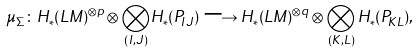Convert formula to latex. <formula><loc_0><loc_0><loc_500><loc_500>\mu _ { \Sigma } \colon H _ { * } ( L M ) ^ { \otimes p } \otimes { \bigotimes _ { ( I , J ) } } H _ { * } ( P _ { I J } ) \longrightarrow H _ { * } ( L M ) ^ { \otimes q } \otimes \bigotimes _ { ( K , L ) } H _ { * } ( P _ { K L } ) ,</formula> 